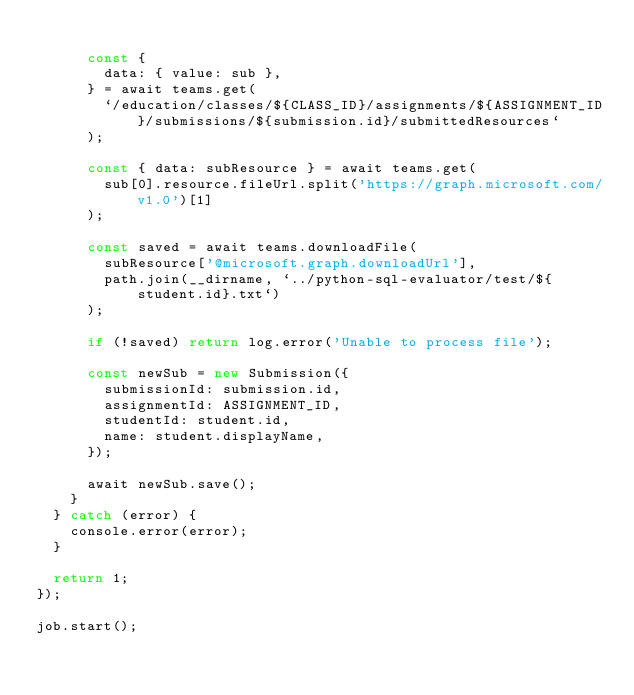Convert code to text. <code><loc_0><loc_0><loc_500><loc_500><_JavaScript_>
      const {
        data: { value: sub },
      } = await teams.get(
        `/education/classes/${CLASS_ID}/assignments/${ASSIGNMENT_ID}/submissions/${submission.id}/submittedResources`
      );

      const { data: subResource } = await teams.get(
        sub[0].resource.fileUrl.split('https://graph.microsoft.com/v1.0')[1]
      );

      const saved = await teams.downloadFile(
        subResource['@microsoft.graph.downloadUrl'],
        path.join(__dirname, `../python-sql-evaluator/test/${student.id}.txt`)
      );

      if (!saved) return log.error('Unable to process file');

      const newSub = new Submission({
        submissionId: submission.id,
        assignmentId: ASSIGNMENT_ID,
        studentId: student.id,
        name: student.displayName,
      });

      await newSub.save();
    }
  } catch (error) {
    console.error(error);
  }

  return 1;
});

job.start();
</code> 